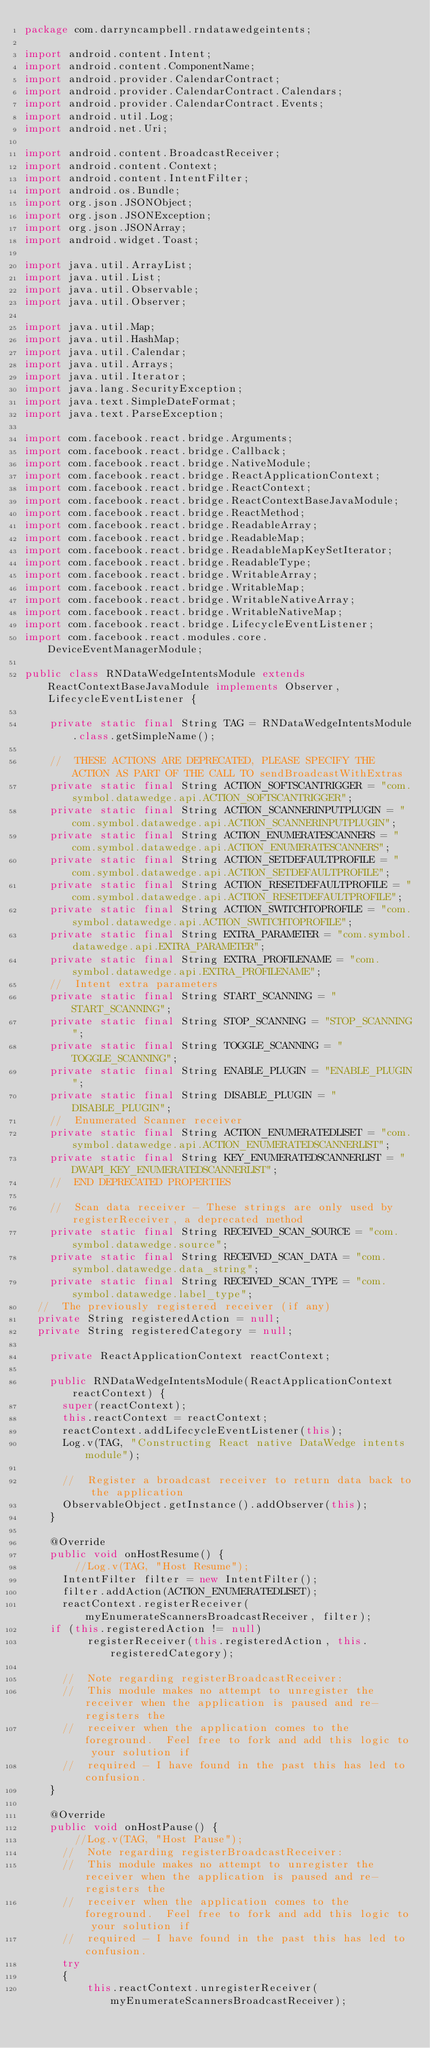Convert code to text. <code><loc_0><loc_0><loc_500><loc_500><_Java_>package com.darryncampbell.rndatawedgeintents;

import android.content.Intent;
import android.content.ComponentName;
import android.provider.CalendarContract;
import android.provider.CalendarContract.Calendars;
import android.provider.CalendarContract.Events;
import android.util.Log;
import android.net.Uri;

import android.content.BroadcastReceiver;
import android.content.Context;
import android.content.IntentFilter;
import android.os.Bundle;
import org.json.JSONObject;
import org.json.JSONException;
import org.json.JSONArray;
import android.widget.Toast;

import java.util.ArrayList;
import java.util.List;
import java.util.Observable;
import java.util.Observer;

import java.util.Map;
import java.util.HashMap;
import java.util.Calendar;
import java.util.Arrays;
import java.util.Iterator;
import java.lang.SecurityException;
import java.text.SimpleDateFormat;
import java.text.ParseException;

import com.facebook.react.bridge.Arguments;
import com.facebook.react.bridge.Callback;
import com.facebook.react.bridge.NativeModule;
import com.facebook.react.bridge.ReactApplicationContext;
import com.facebook.react.bridge.ReactContext;
import com.facebook.react.bridge.ReactContextBaseJavaModule;
import com.facebook.react.bridge.ReactMethod;
import com.facebook.react.bridge.ReadableArray;
import com.facebook.react.bridge.ReadableMap;
import com.facebook.react.bridge.ReadableMapKeySetIterator;
import com.facebook.react.bridge.ReadableType;
import com.facebook.react.bridge.WritableArray;
import com.facebook.react.bridge.WritableMap;
import com.facebook.react.bridge.WritableNativeArray;
import com.facebook.react.bridge.WritableNativeMap;
import com.facebook.react.bridge.LifecycleEventListener;
import com.facebook.react.modules.core.DeviceEventManagerModule;

public class RNDataWedgeIntentsModule extends ReactContextBaseJavaModule implements Observer, LifecycleEventListener {

    private static final String TAG = RNDataWedgeIntentsModule.class.getSimpleName();

    //  THESE ACTIONS ARE DEPRECATED, PLEASE SPECIFY THE ACTION AS PART OF THE CALL TO sendBroadcastWithExtras
    private static final String ACTION_SOFTSCANTRIGGER = "com.symbol.datawedge.api.ACTION_SOFTSCANTRIGGER";
    private static final String ACTION_SCANNERINPUTPLUGIN = "com.symbol.datawedge.api.ACTION_SCANNERINPUTPLUGIN";
    private static final String ACTION_ENUMERATESCANNERS = "com.symbol.datawedge.api.ACTION_ENUMERATESCANNERS";
    private static final String ACTION_SETDEFAULTPROFILE = "com.symbol.datawedge.api.ACTION_SETDEFAULTPROFILE";
    private static final String ACTION_RESETDEFAULTPROFILE = "com.symbol.datawedge.api.ACTION_RESETDEFAULTPROFILE";
    private static final String ACTION_SWITCHTOPROFILE = "com.symbol.datawedge.api.ACTION_SWITCHTOPROFILE";
    private static final String EXTRA_PARAMETER = "com.symbol.datawedge.api.EXTRA_PARAMETER";
    private static final String EXTRA_PROFILENAME = "com.symbol.datawedge.api.EXTRA_PROFILENAME";
    //  Intent extra parameters
    private static final String START_SCANNING = "START_SCANNING";
    private static final String STOP_SCANNING = "STOP_SCANNING";
    private static final String TOGGLE_SCANNING = "TOGGLE_SCANNING";
    private static final String ENABLE_PLUGIN = "ENABLE_PLUGIN";
    private static final String DISABLE_PLUGIN = "DISABLE_PLUGIN";
    //  Enumerated Scanner receiver
    private static final String ACTION_ENUMERATEDLISET = "com.symbol.datawedge.api.ACTION_ENUMERATEDSCANNERLIST";
    private static final String KEY_ENUMERATEDSCANNERLIST = "DWAPI_KEY_ENUMERATEDSCANNERLIST";
    //  END DEPRECATED PROPERTIES

    //  Scan data receiver - These strings are only used by registerReceiver, a deprecated method
    private static final String RECEIVED_SCAN_SOURCE = "com.symbol.datawedge.source";
    private static final String RECEIVED_SCAN_DATA = "com.symbol.datawedge.data_string";
    private static final String RECEIVED_SCAN_TYPE = "com.symbol.datawedge.label_type";
	//  The previously registered receiver (if any)
	private String registeredAction = null;
	private String registeredCategory = null;

    private ReactApplicationContext reactContext;

    public RNDataWedgeIntentsModule(ReactApplicationContext reactContext) {
      super(reactContext);
      this.reactContext = reactContext;
      reactContext.addLifecycleEventListener(this);
      Log.v(TAG, "Constructing React native DataWedge intents module");

      //  Register a broadcast receiver to return data back to the application
      ObservableObject.getInstance().addObserver(this);
    }

    @Override
    public void onHostResume() {
        //Log.v(TAG, "Host Resume");
      IntentFilter filter = new IntentFilter();
      filter.addAction(ACTION_ENUMERATEDLISET);
      reactContext.registerReceiver(myEnumerateScannersBroadcastReceiver, filter);
	  if (this.registeredAction != null)
          registerReceiver(this.registeredAction, this.registeredCategory);
          
      //  Note regarding registerBroadcastReceiver:
      //  This module makes no attempt to unregister the receiver when the application is paused and re-registers the
      //  receiver when the application comes to the foreground.  Feel free to fork and add this logic to your solution if
      //  required - I have found in the past this has led to confusion.
    }

    @Override
    public void onHostPause() {
        //Log.v(TAG, "Host Pause");
      //  Note regarding registerBroadcastReceiver:
      //  This module makes no attempt to unregister the receiver when the application is paused and re-registers the
      //  receiver when the application comes to the foreground.  Feel free to fork and add this logic to your solution if
      //  required - I have found in the past this has led to confusion.
      try
      {
          this.reactContext.unregisterReceiver(myEnumerateScannersBroadcastReceiver);</code> 